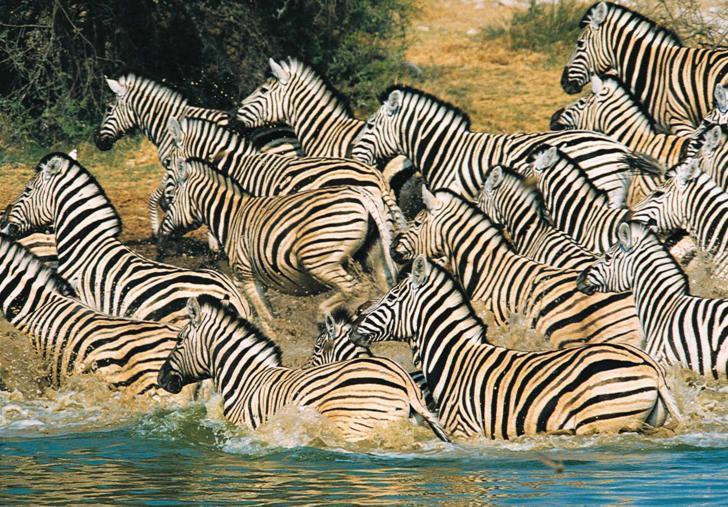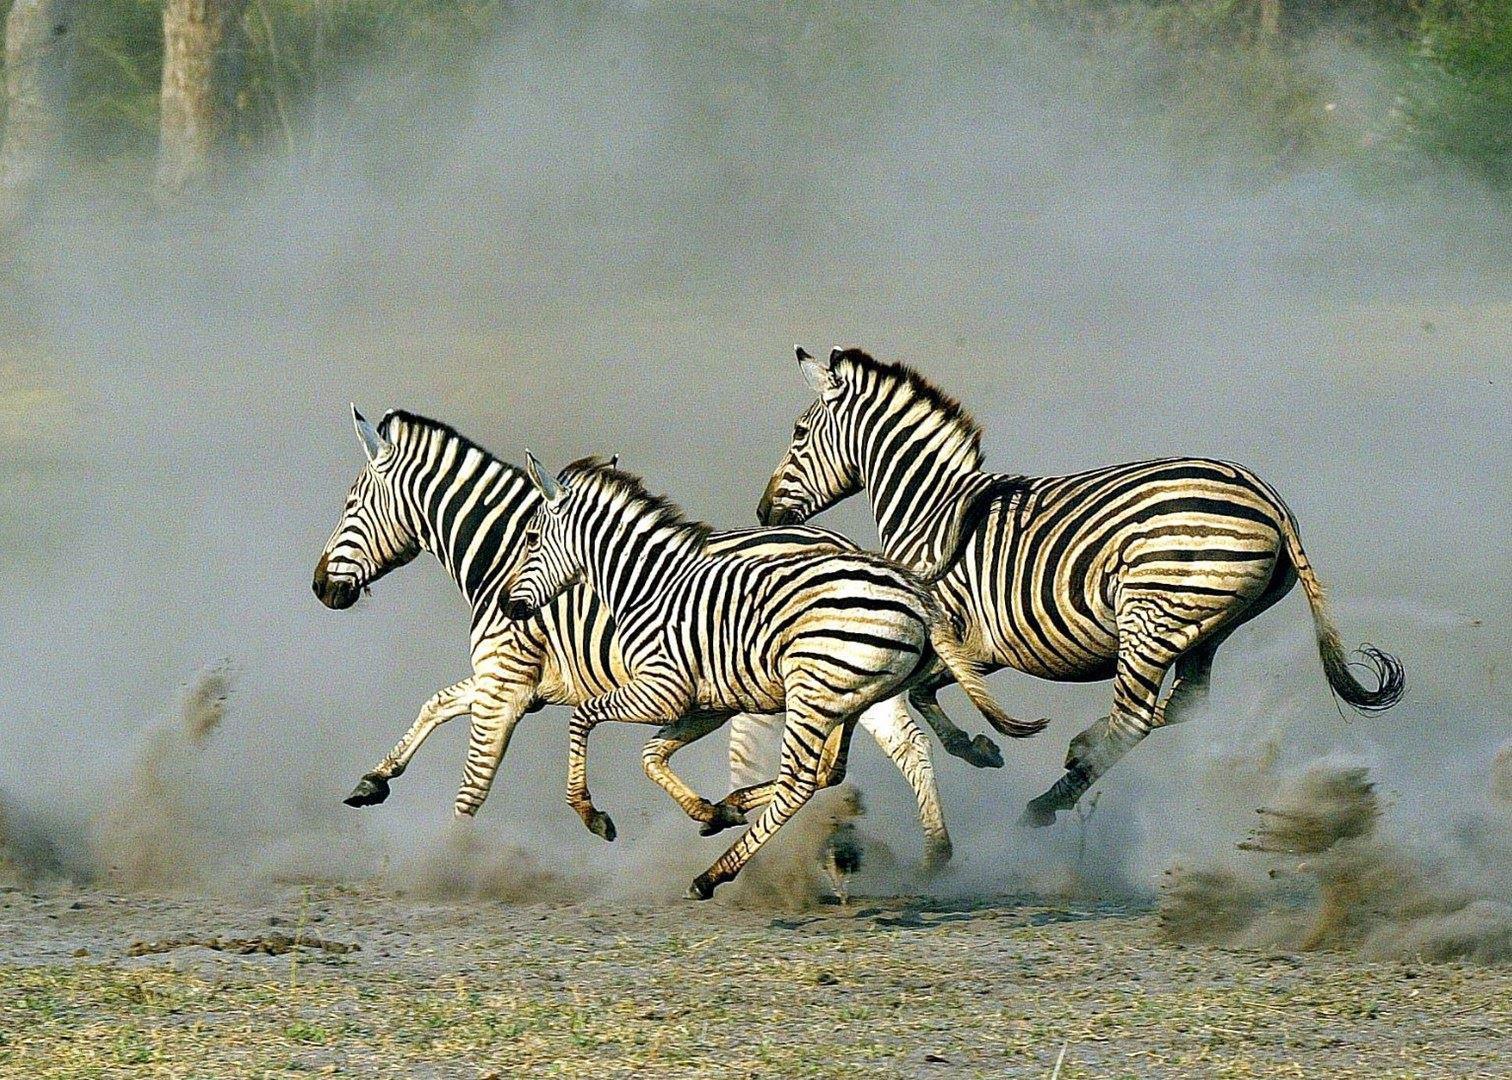The first image is the image on the left, the second image is the image on the right. Analyze the images presented: Is the assertion "One image shows at least four zebras running forward, and the other image shows at least two zebras running leftward." valid? Answer yes or no. No. The first image is the image on the left, the second image is the image on the right. For the images displayed, is the sentence "There are two zebras next to each other moving left and forward." factually correct? Answer yes or no. No. 